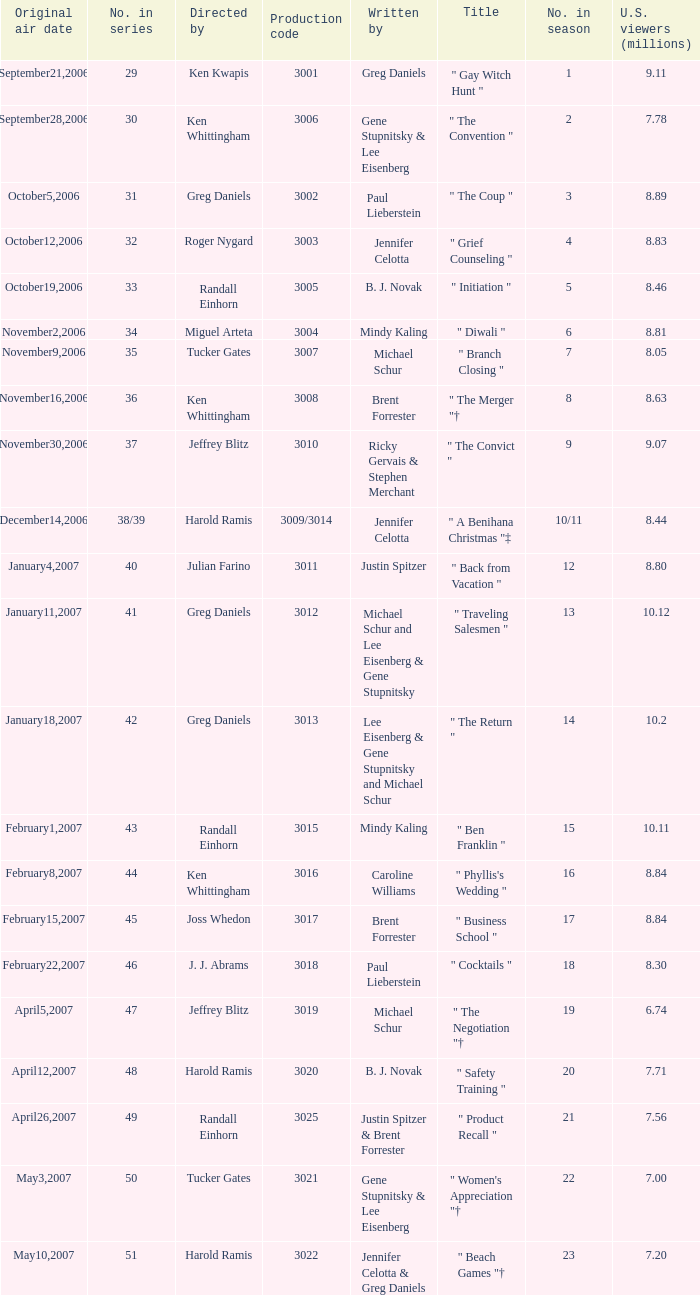Name the number in the series for when the viewers is 7.78 30.0. 